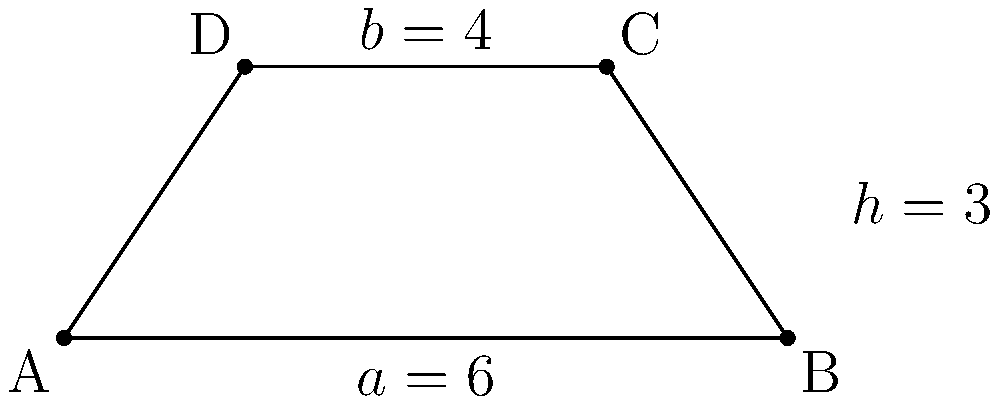As a Software Developer new to PowerShell, imagine you're tasked with creating a script to calculate the area of a trapezoid. Given a trapezoid with parallel sides $a = 6$ units and $b = 4$ units, and a height $h = 3$ units, what is its area? To find the area of a trapezoid, we can follow these steps:

1. Recall the formula for the area of a trapezoid:
   $$\text{Area} = \frac{1}{2}(a + b)h$$
   where $a$ and $b$ are the lengths of the parallel sides, and $h$ is the height.

2. Substitute the given values into the formula:
   $$\text{Area} = \frac{1}{2}(6 + 4) \cdot 3$$

3. Simplify the expression inside the parentheses:
   $$\text{Area} = \frac{1}{2}(10) \cdot 3$$

4. Multiply:
   $$\text{Area} = 5 \cdot 3 = 15$$

Therefore, the area of the trapezoid is 15 square units.

In PowerShell, you could calculate this using:
```powershell
$a = 6
$b = 4
$h = 3
$area = 0.5 * ($a + $b) * $h
```
Answer: 15 square units 